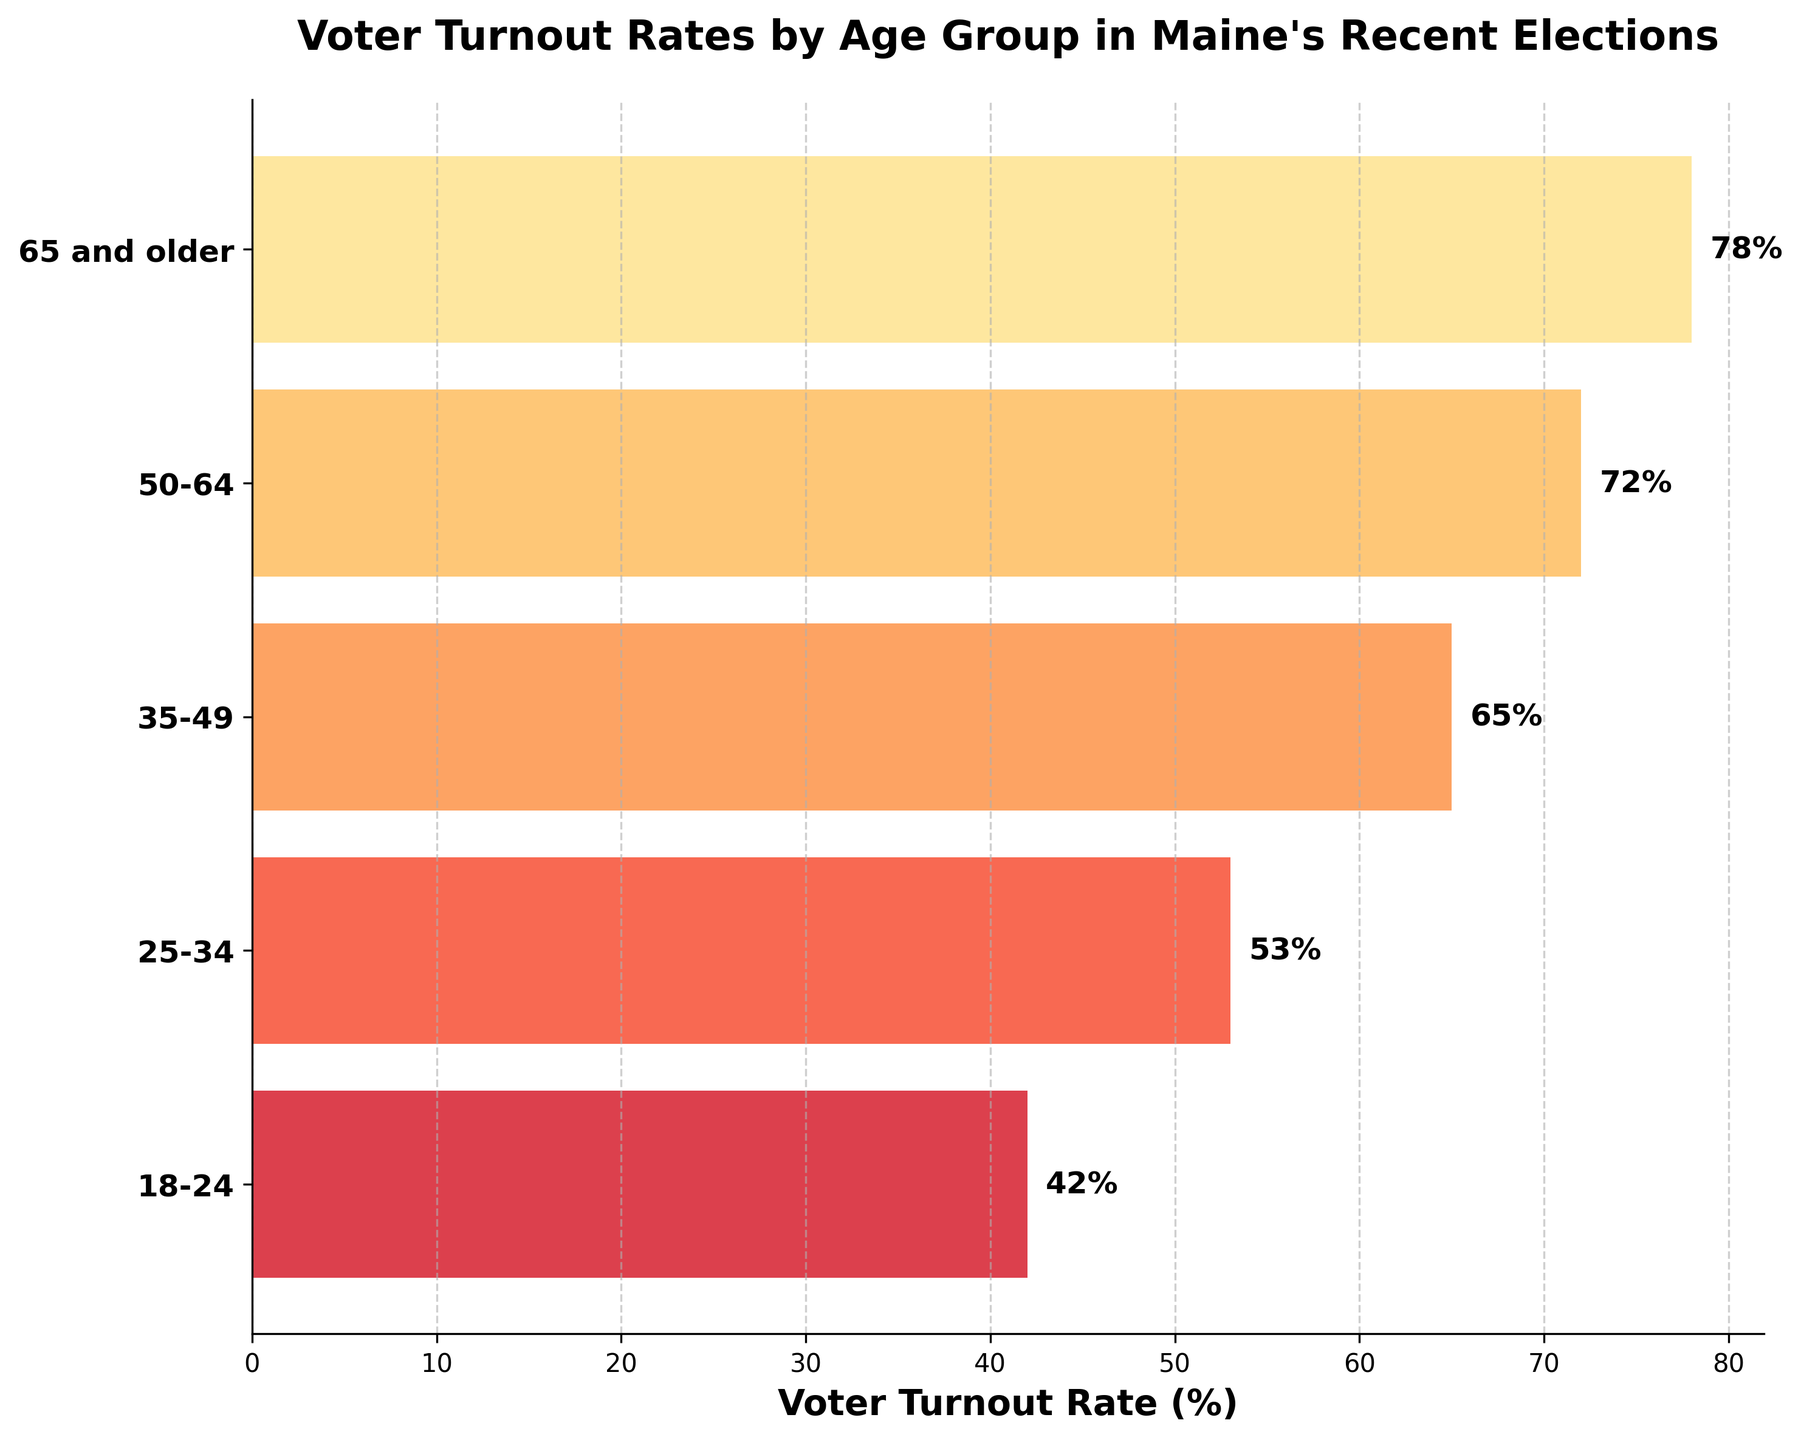What's the title of the chart? The title of the chart is displayed at the top of the figure. In this case, it reads "Voter Turnout Rates by Age Group in Maine's Recent Elections".
Answer: Voter Turnout Rates by Age Group in Maine's Recent Elections What is the voter turnout rate for the age group 65 and older? The voter turnout rate for each age group is shown as percentages on the bars. The bar corresponding to the age group "65 and older" shows 78%.
Answer: 78% How many age groups are represented in the chart? The age groups are represented on the y-axis, and each bar corresponds to a different age group. There are five bars, so there are five age groups represented.
Answer: Five Which age group has the lowest voter turnout rate? By observing the bars, the lowest bar corresponds to the age group "18-24," with a voter turnout rate of 42%.
Answer: 18-24 What is the difference in voter turnout rate between the age groups 50-64 and 25-34? The voter turnout rate for the age group 50-64 is 72%, and for the age group 25-34 is 53%. Subtracting 53 from 72 gives the difference.
Answer: 19% What is the average voter turnout rate across all age groups? The voter turnout rates are 78%, 72%, 65%, 53%, and 42%. Adding these gives 310%, and dividing by 5 (the number of age groups) gives the average.
Answer: 62% How does the voter turnout rate for the age group 35-49 compare to the overall average? The voter turnout rate for the age group 35-49 is 65%. The average voter turnout rate across all age groups is 62%. 65% is slightly higher than 62%.
Answer: Higher Which two consecutive age groups show the closest voter turnout rates? By comparing the differences in voter turnout rates between consecutive age groups, 65% (35-49) and 72% (50-64) have a difference of 7%, while others have larger gaps.
Answer: 35-49 and 50-64 What's the median voter turnout rate among the age groups? The voter turnout rates in ascending order are 42%, 53%, 65%, 72%, and 78%. The middle value is 65%, making it the median.
Answer: 65% What visual elements help to distinguish the different age groups on the chart? The chart uses colors from a range of shades and labels each bar clearly. Each bar has an age group label and a percentage value at the end of the bar to help distinguish them.
Answer: Colors and labels 